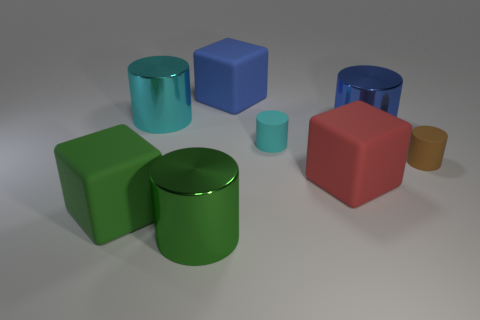There is a large blue metal object behind the big red cube; what is its shape?
Offer a terse response. Cylinder. There is a big blue thing that is the same material as the green cylinder; what shape is it?
Your answer should be compact. Cylinder. There is a green matte cube that is behind the green metallic cylinder; does it have the same size as the blue matte thing?
Make the answer very short. Yes. How many things are either blocks that are on the left side of the red object or big metal objects that are behind the brown thing?
Ensure brevity in your answer.  4. How many rubber things are small cyan cylinders or green blocks?
Give a very brief answer. 2. What is the shape of the red matte thing?
Ensure brevity in your answer.  Cube. Is the material of the big cyan thing the same as the big green cylinder?
Give a very brief answer. Yes. Are there any tiny cyan matte cylinders that are on the left side of the green thing that is right of the cylinder that is left of the green cylinder?
Make the answer very short. No. What number of other objects are there of the same shape as the big red rubber object?
Your answer should be compact. 2. The big rubber thing that is on the right side of the large green shiny cylinder and in front of the large cyan thing has what shape?
Your response must be concise. Cube. 